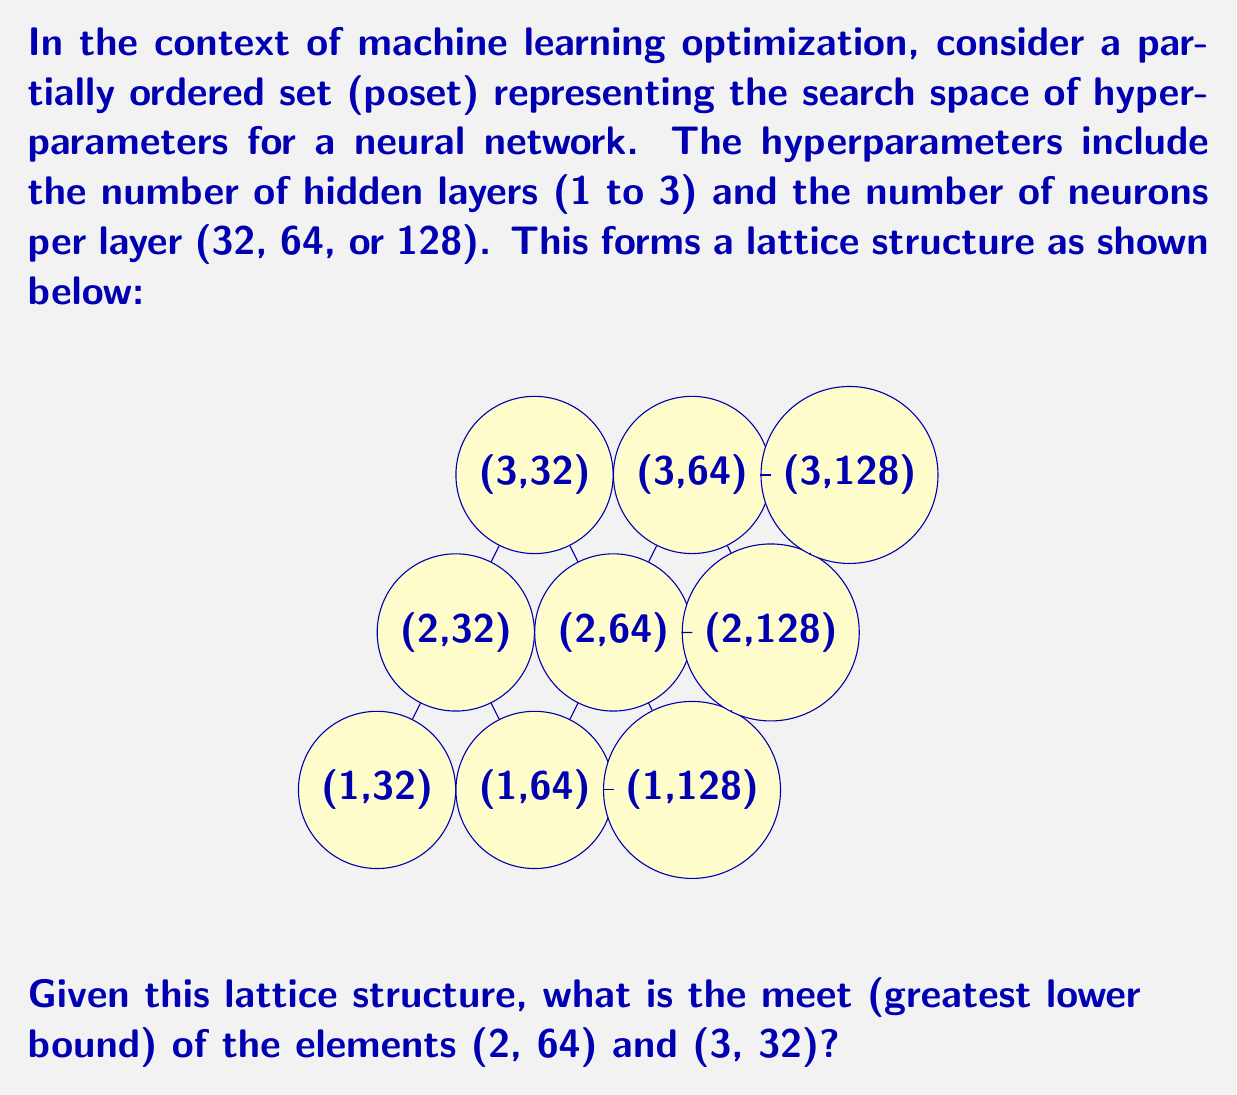Give your solution to this math problem. To solve this problem, we need to understand the concept of meet in lattice theory and how it applies to our hyperparameter optimization scenario. Let's break it down step-by-step:

1) In a lattice, the meet of two elements is their greatest lower bound. It's the largest element that is less than or equal to both given elements.

2) In our lattice, we have two parameters: number of layers and neurons per layer. The order is defined as follows:
   - For layers: 1 < 2 < 3
   - For neurons: 32 < 64 < 128

3) We need to find the meet of (2, 64) and (3, 32). Let's compare each parameter:

   - Layers: 2 < 3, so the lower bound for layers is 2
   - Neurons: 32 < 64, so the lower bound for neurons is 32

4) Therefore, we're looking for an element that has at most 2 layers and at most 32 neurons per layer.

5) Looking at our lattice, the element that satisfies these conditions and is the greatest such element is (2, 32).

6) We can verify that (2, 32) is indeed less than or equal to both (2, 64) and (3, 32) in our partial order:
   (2, 32) ≤ (2, 64) and (2, 32) ≤ (3, 32)

7) Any other lower bound, such as (1, 32), would be less than (2, 32), so (2, 32) is indeed the greatest lower bound.

Thus, the meet of (2, 64) and (3, 32) in this lattice is (2, 32).
Answer: (2, 32) 